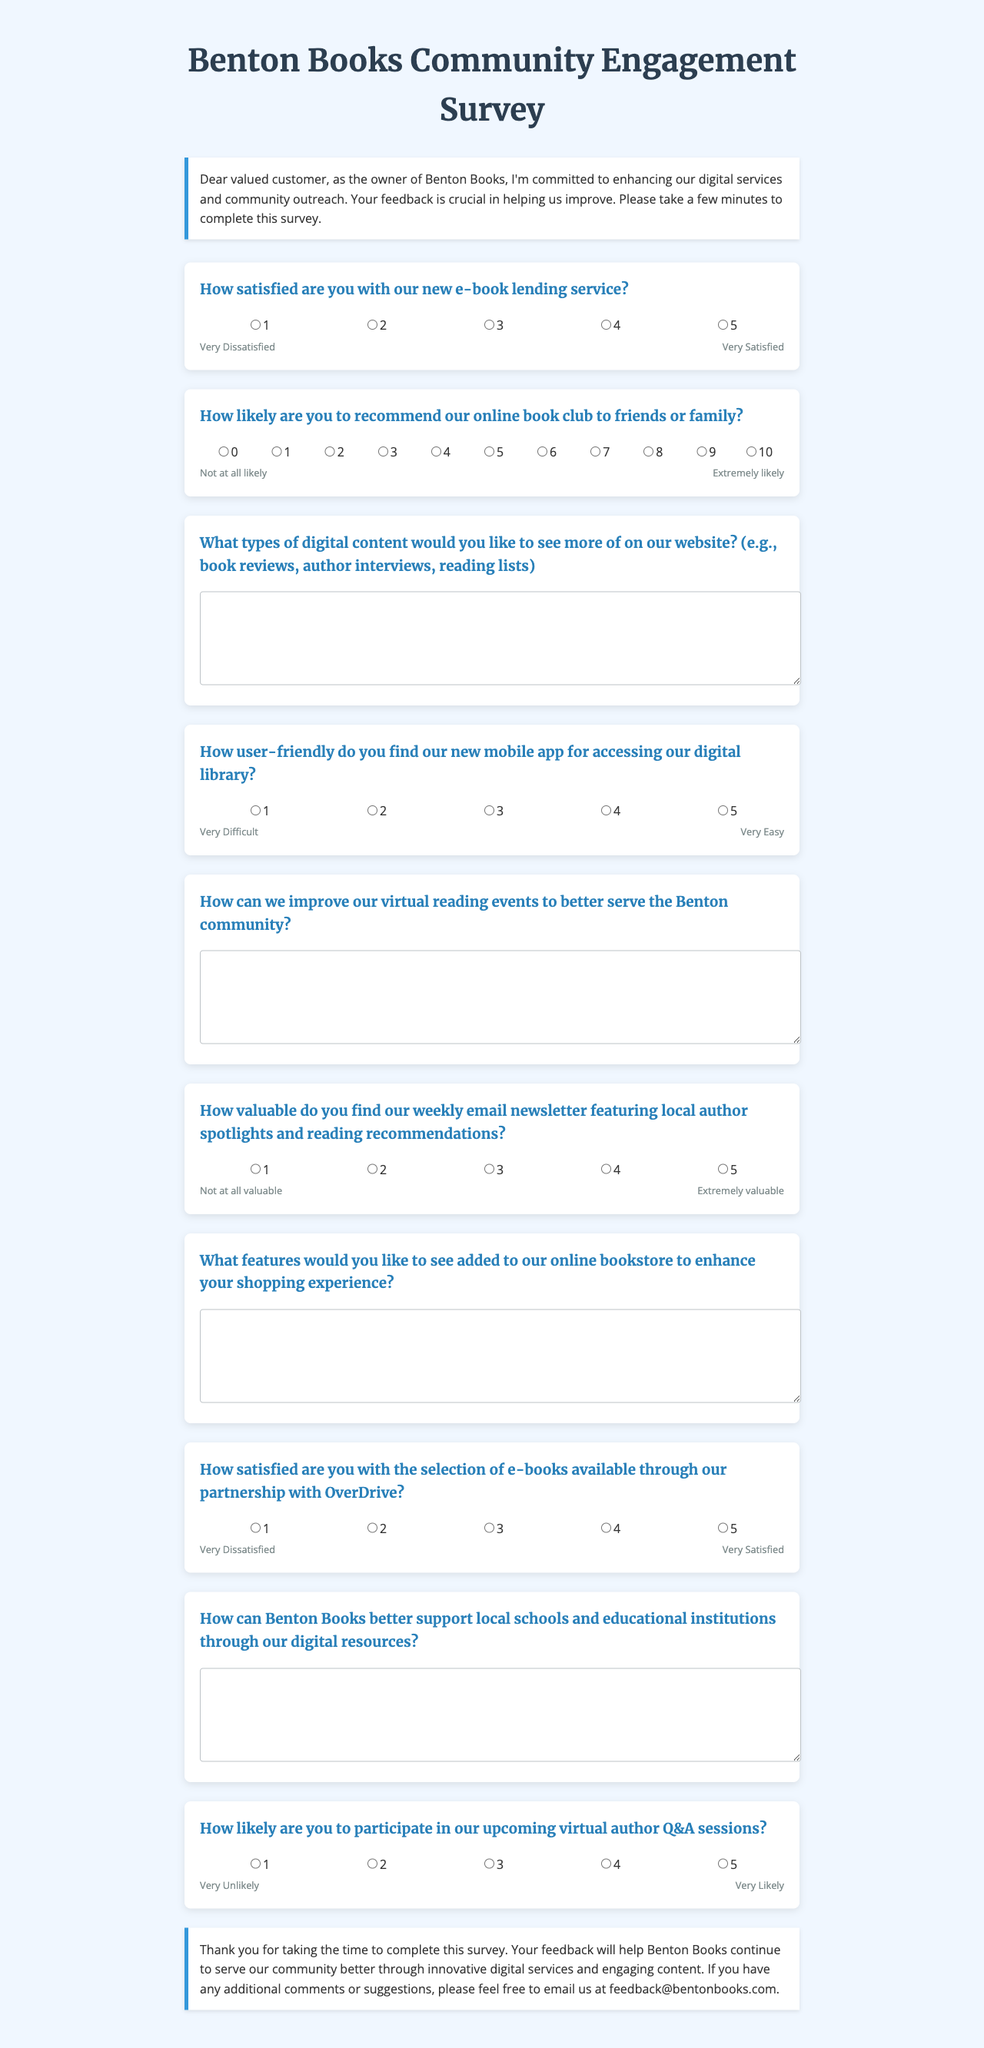What is the title of the survey? The title of the survey is indicated at the top of the document.
Answer: Benton Books Community Engagement Survey How many rating questions are included in the survey? The survey lists several questions of different types, and the number of rating questions can be counted.
Answer: 5 What is the highest rating on the satisfaction scale for the e-book lending service? The scale provided in the survey shows the range of ratings available.
Answer: 5 What types of digital content does the survey ask about in the open-ended question? The survey specifies examples of digital content that the respondent might want to see more of.
Answer: Book reviews, author interviews, reading lists How likely are respondents asked to participate in upcoming virtual author Q&A sessions? The document includes a specific question regarding the likelihood of participation in these sessions, indicating a rating scale used.
Answer: 5 What is the closing statement thanking respondents for their feedback? The closing statement is provided at the end of the survey document.
Answer: Thank you for taking the time to complete this survey What is the email address for feedback mentioned in the closing text? This information can be retrieved directly from the closing text in the document.
Answer: feedback@bentonbooks.com 